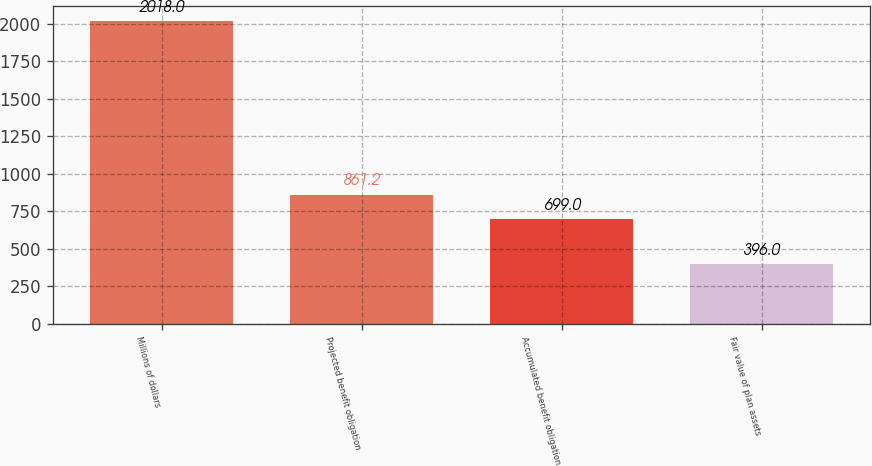Convert chart. <chart><loc_0><loc_0><loc_500><loc_500><bar_chart><fcel>Millions of dollars<fcel>Projected benefit obligation<fcel>Accumulated benefit obligation<fcel>Fair value of plan assets<nl><fcel>2018<fcel>861.2<fcel>699<fcel>396<nl></chart> 